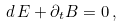<formula> <loc_0><loc_0><loc_500><loc_500>d \, E + { \partial _ { t } B } = 0 \, ,</formula> 